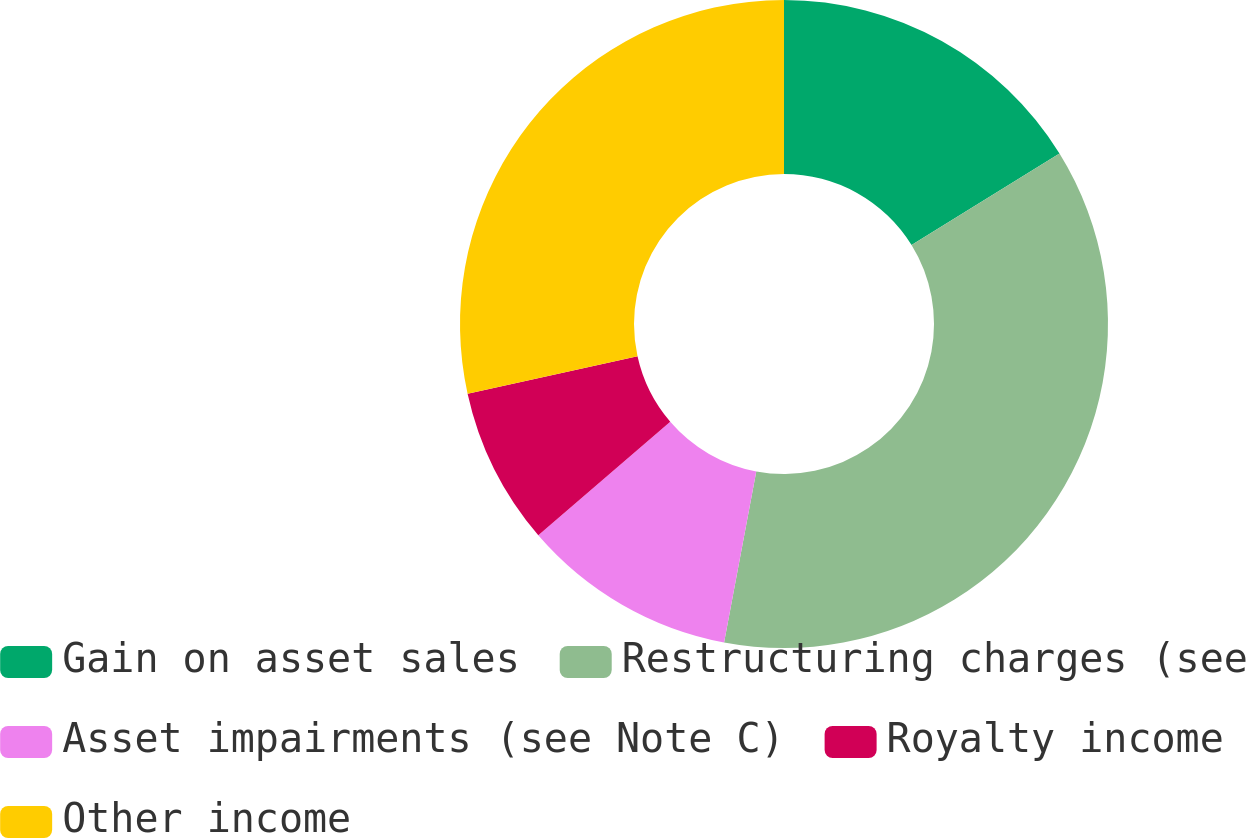Convert chart. <chart><loc_0><loc_0><loc_500><loc_500><pie_chart><fcel>Gain on asset sales<fcel>Restructuring charges (see<fcel>Asset impairments (see Note C)<fcel>Royalty income<fcel>Other income<nl><fcel>16.18%<fcel>36.78%<fcel>10.74%<fcel>7.85%<fcel>28.45%<nl></chart> 